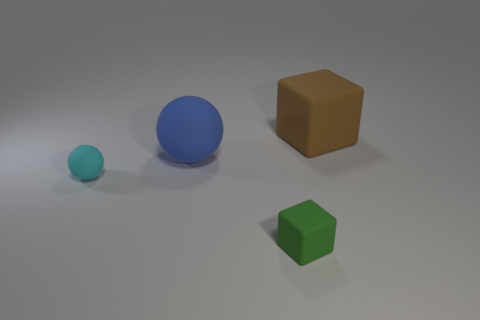Add 2 cyan things. How many objects exist? 6 Subtract all tiny purple objects. Subtract all large blue matte objects. How many objects are left? 3 Add 1 small green blocks. How many small green blocks are left? 2 Add 4 large gray metal cylinders. How many large gray metal cylinders exist? 4 Subtract 1 brown cubes. How many objects are left? 3 